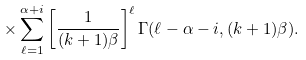<formula> <loc_0><loc_0><loc_500><loc_500>\times \sum _ { \ell = 1 } ^ { \alpha + i } \left [ \frac { 1 } { ( k + 1 ) \beta } \right ] ^ { \ell } \Gamma ( \ell - \alpha - i , ( k + 1 ) \beta ) .</formula> 